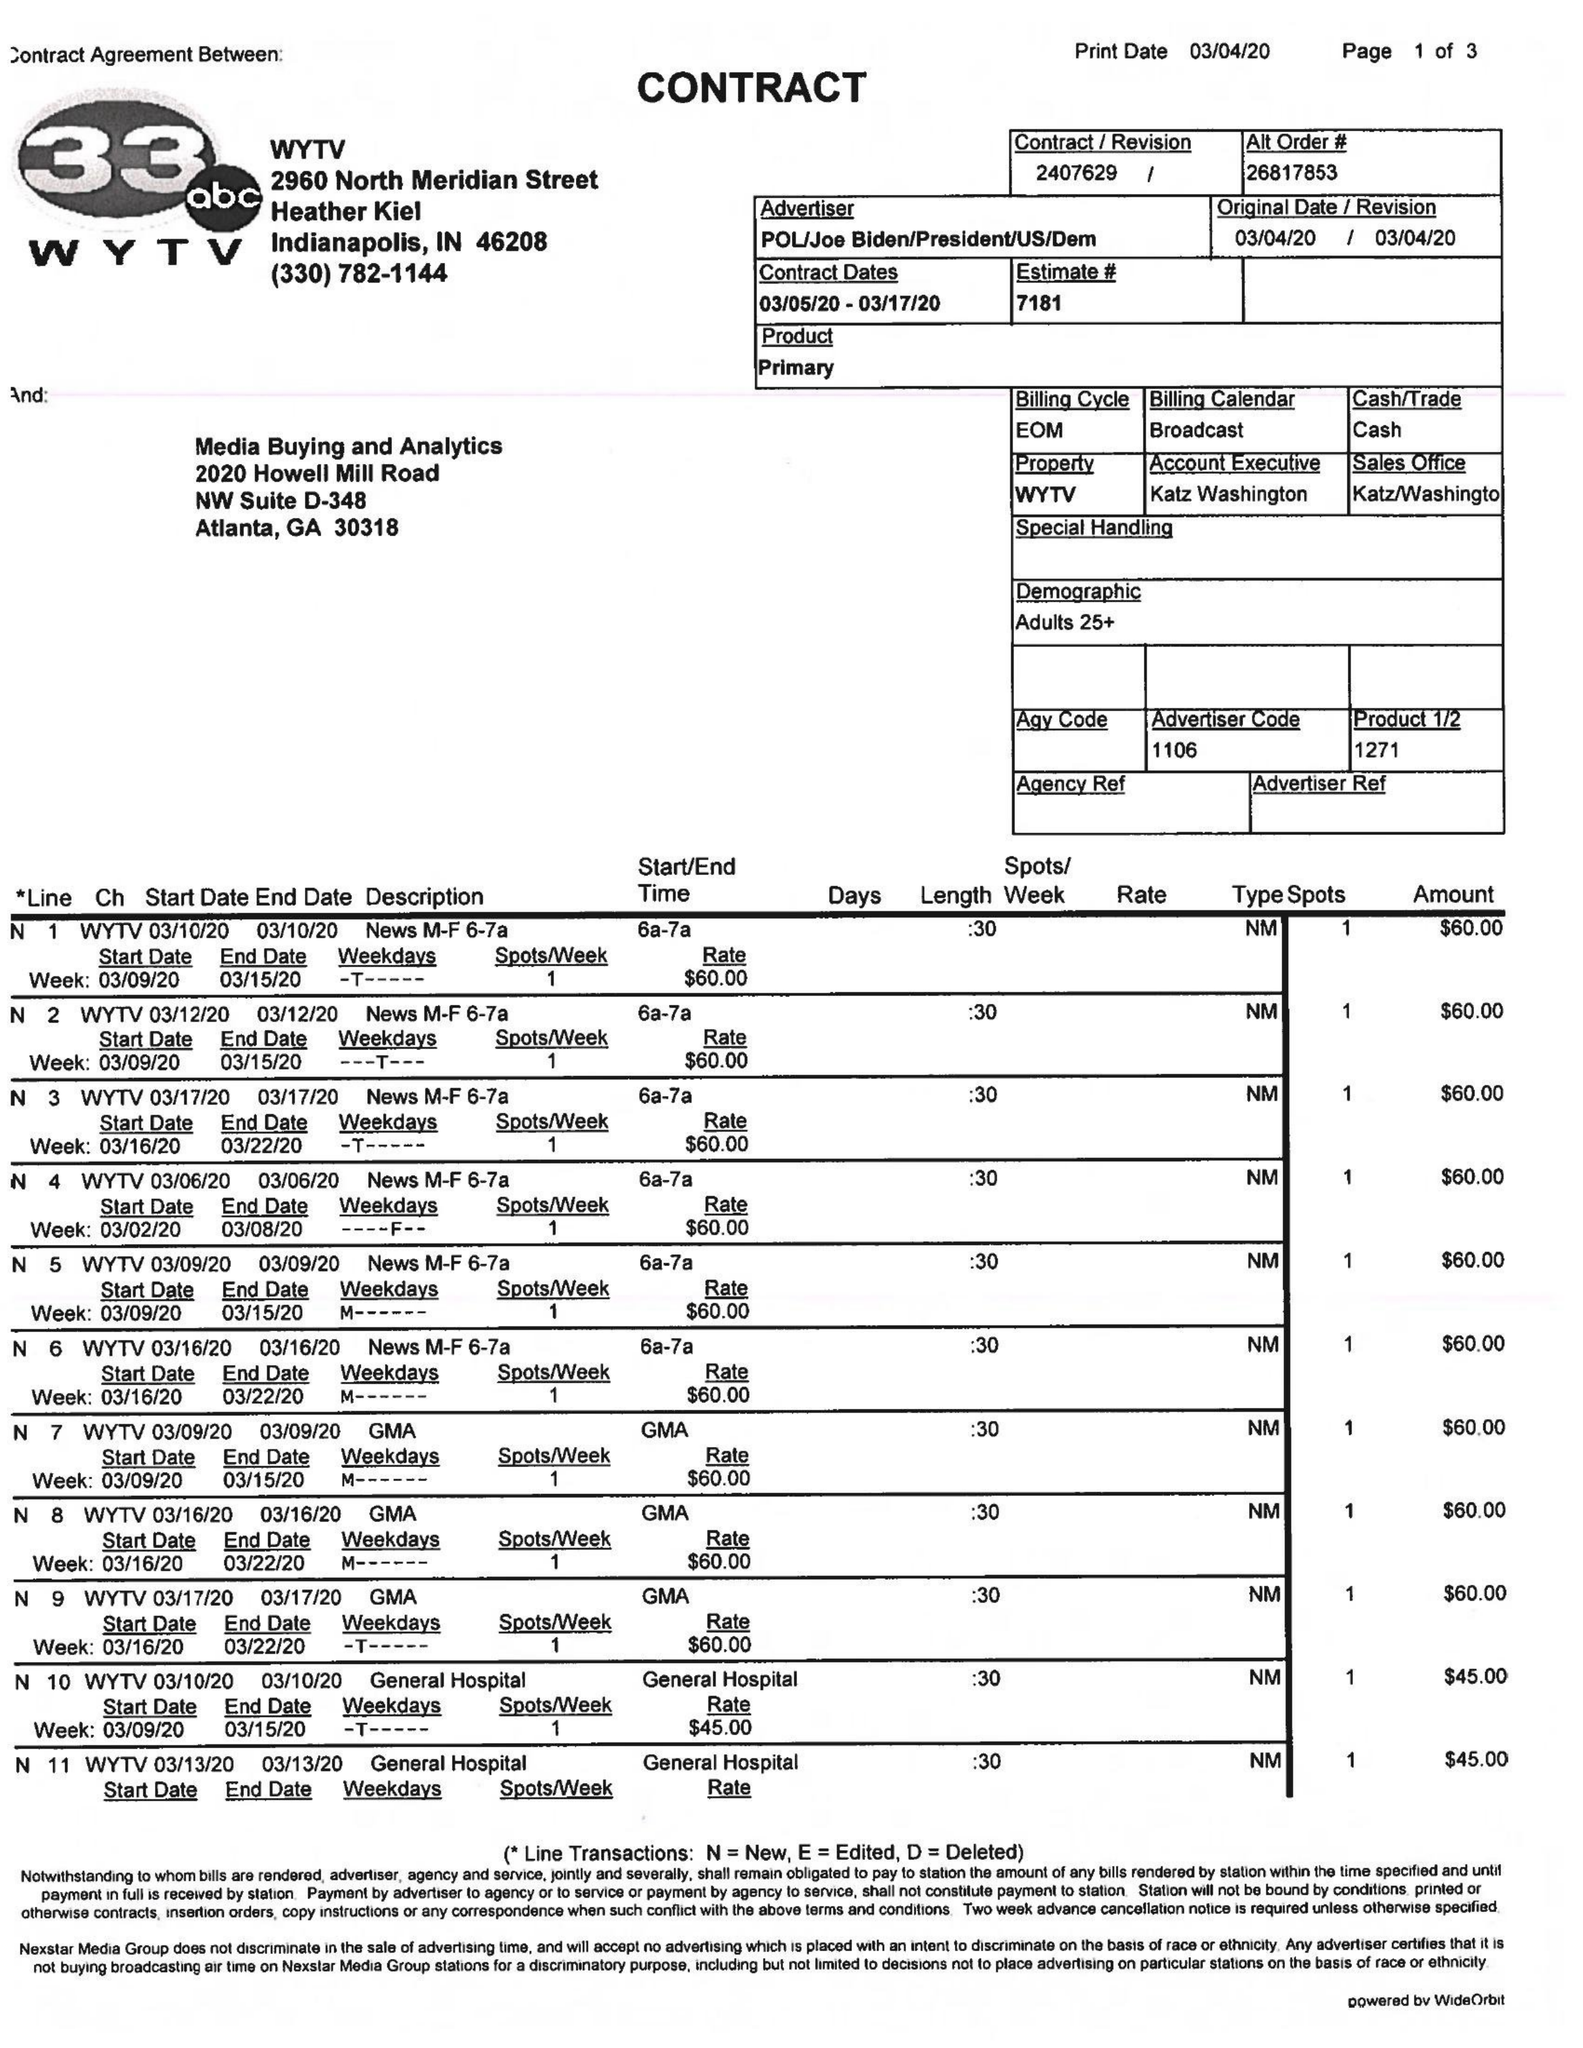What is the value for the advertiser?
Answer the question using a single word or phrase. POL/JOEBIDEN/PRESIDENT/US/DEM 